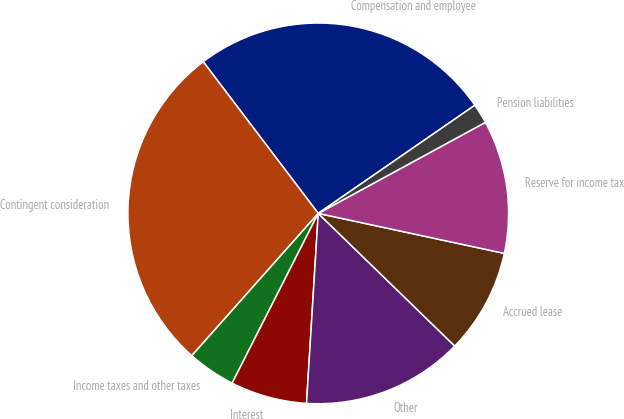Convert chart. <chart><loc_0><loc_0><loc_500><loc_500><pie_chart><fcel>Compensation and employee<fcel>Contingent consideration<fcel>Income taxes and other taxes<fcel>Interest<fcel>Other<fcel>Accrued lease<fcel>Reserve for income tax<fcel>Pension liabilities<nl><fcel>25.71%<fcel>28.11%<fcel>4.09%<fcel>6.49%<fcel>13.71%<fcel>8.9%<fcel>11.31%<fcel>1.68%<nl></chart> 